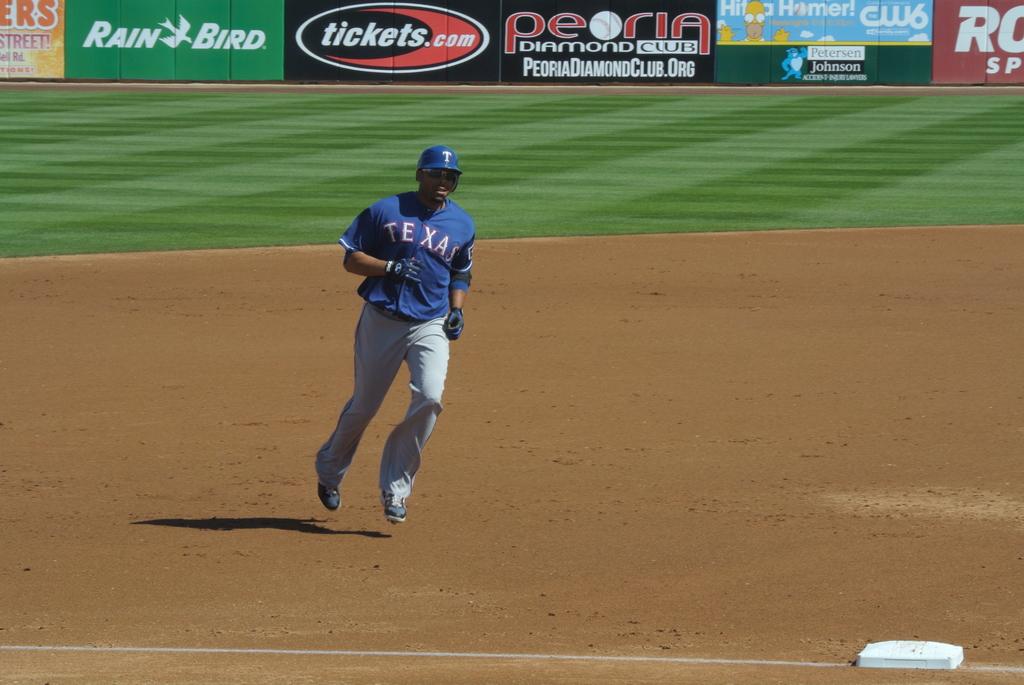What website is being advertised on the black and red billboard?
Your response must be concise. Tickets.com. 